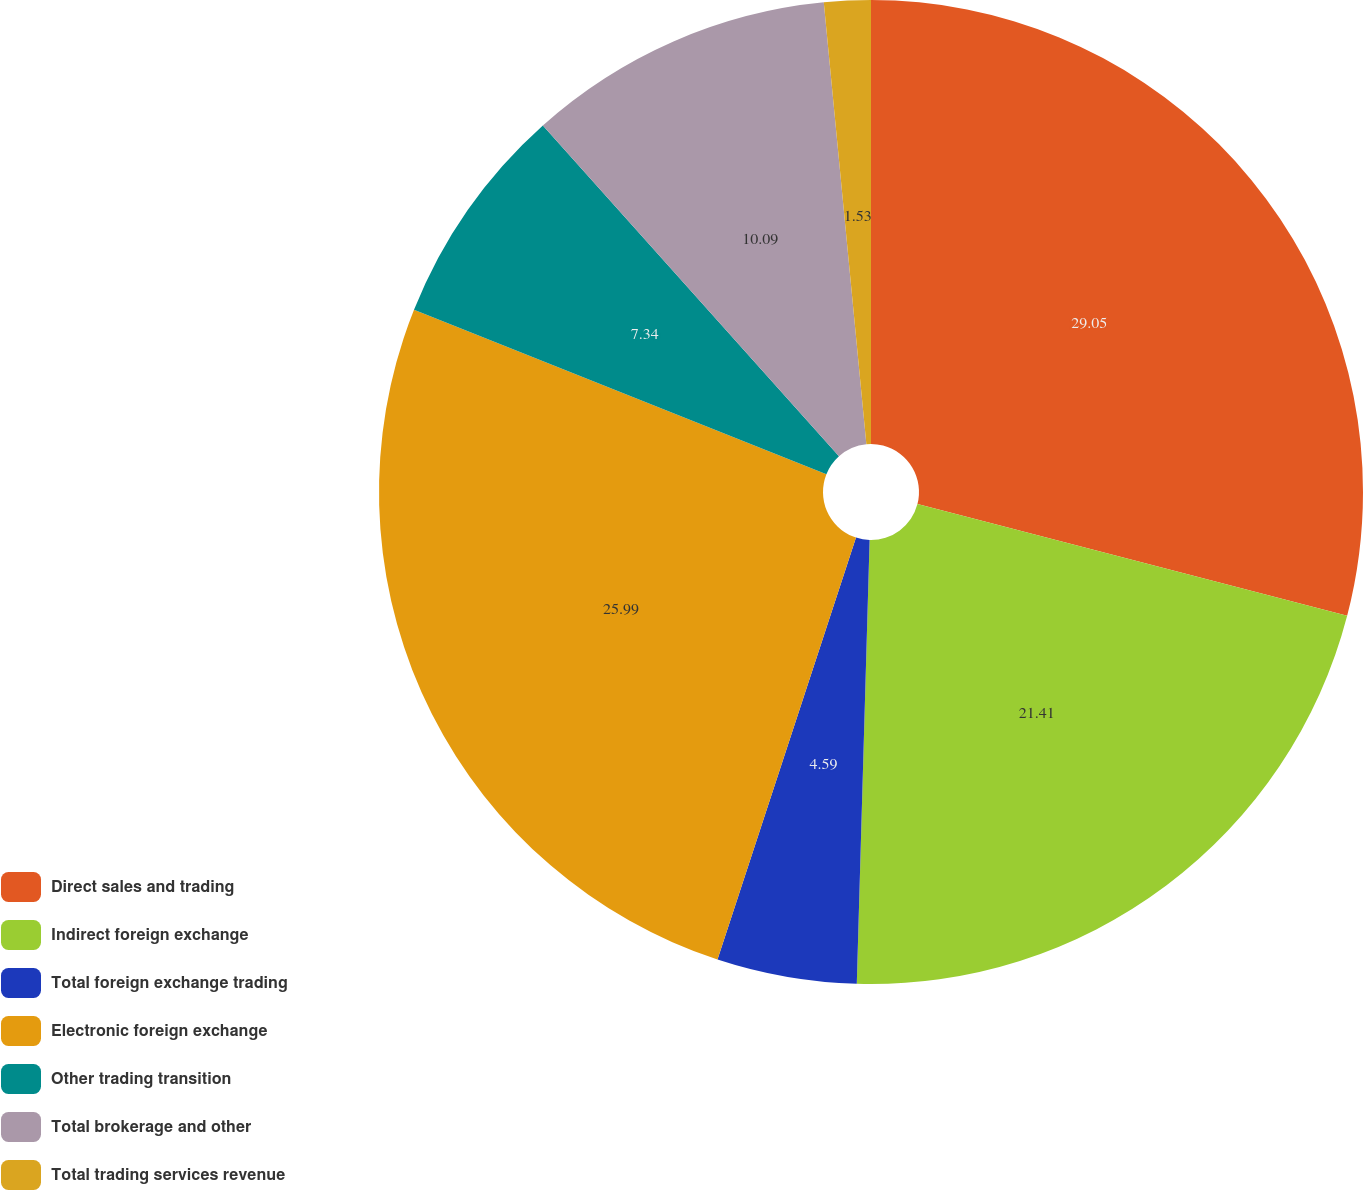Convert chart. <chart><loc_0><loc_0><loc_500><loc_500><pie_chart><fcel>Direct sales and trading<fcel>Indirect foreign exchange<fcel>Total foreign exchange trading<fcel>Electronic foreign exchange<fcel>Other trading transition<fcel>Total brokerage and other<fcel>Total trading services revenue<nl><fcel>29.05%<fcel>21.41%<fcel>4.59%<fcel>25.99%<fcel>7.34%<fcel>10.09%<fcel>1.53%<nl></chart> 